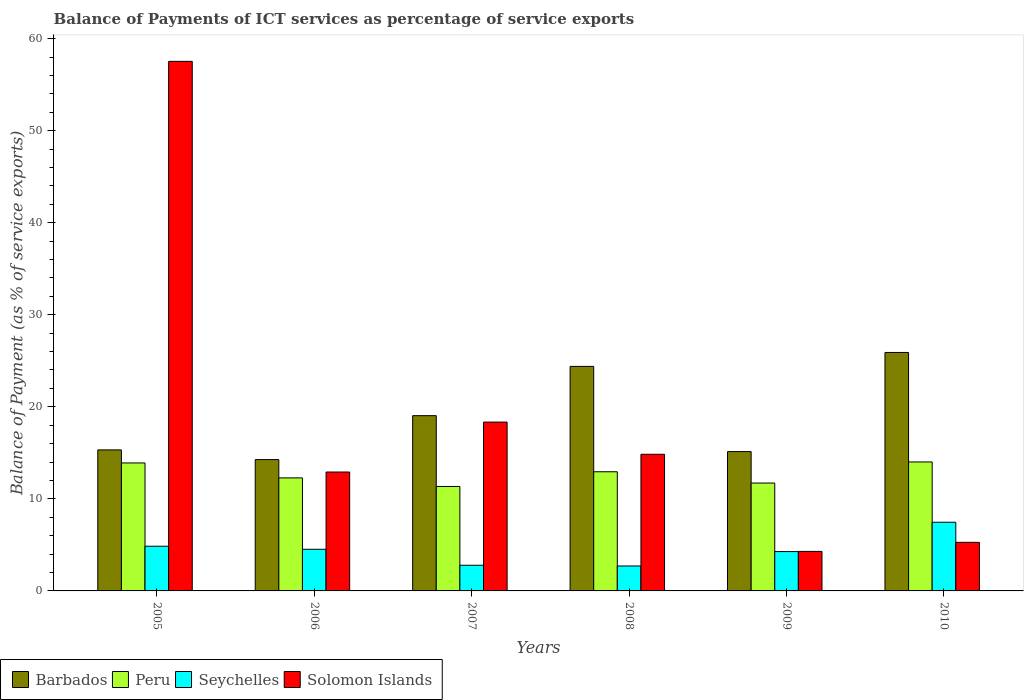How many groups of bars are there?
Give a very brief answer. 6. Are the number of bars on each tick of the X-axis equal?
Give a very brief answer. Yes. How many bars are there on the 5th tick from the left?
Ensure brevity in your answer.  4. How many bars are there on the 2nd tick from the right?
Your answer should be very brief. 4. What is the label of the 2nd group of bars from the left?
Offer a very short reply. 2006. What is the balance of payments of ICT services in Peru in 2007?
Offer a very short reply. 11.35. Across all years, what is the maximum balance of payments of ICT services in Peru?
Offer a terse response. 14.01. Across all years, what is the minimum balance of payments of ICT services in Solomon Islands?
Your answer should be very brief. 4.29. In which year was the balance of payments of ICT services in Barbados minimum?
Give a very brief answer. 2006. What is the total balance of payments of ICT services in Peru in the graph?
Your answer should be very brief. 76.2. What is the difference between the balance of payments of ICT services in Solomon Islands in 2008 and that in 2010?
Your response must be concise. 9.57. What is the difference between the balance of payments of ICT services in Barbados in 2008 and the balance of payments of ICT services in Solomon Islands in 2005?
Ensure brevity in your answer.  -33.13. What is the average balance of payments of ICT services in Peru per year?
Your response must be concise. 12.7. In the year 2007, what is the difference between the balance of payments of ICT services in Peru and balance of payments of ICT services in Seychelles?
Make the answer very short. 8.56. What is the ratio of the balance of payments of ICT services in Seychelles in 2005 to that in 2007?
Keep it short and to the point. 1.74. Is the difference between the balance of payments of ICT services in Peru in 2008 and 2010 greater than the difference between the balance of payments of ICT services in Seychelles in 2008 and 2010?
Your response must be concise. Yes. What is the difference between the highest and the second highest balance of payments of ICT services in Peru?
Ensure brevity in your answer.  0.11. What is the difference between the highest and the lowest balance of payments of ICT services in Seychelles?
Your answer should be very brief. 4.75. Is the sum of the balance of payments of ICT services in Solomon Islands in 2006 and 2007 greater than the maximum balance of payments of ICT services in Seychelles across all years?
Keep it short and to the point. Yes. Is it the case that in every year, the sum of the balance of payments of ICT services in Barbados and balance of payments of ICT services in Seychelles is greater than the sum of balance of payments of ICT services in Peru and balance of payments of ICT services in Solomon Islands?
Ensure brevity in your answer.  Yes. What does the 2nd bar from the left in 2005 represents?
Provide a short and direct response. Peru. What does the 1st bar from the right in 2007 represents?
Your response must be concise. Solomon Islands. Is it the case that in every year, the sum of the balance of payments of ICT services in Peru and balance of payments of ICT services in Seychelles is greater than the balance of payments of ICT services in Solomon Islands?
Provide a succinct answer. No. What is the difference between two consecutive major ticks on the Y-axis?
Offer a terse response. 10. Where does the legend appear in the graph?
Give a very brief answer. Bottom left. How many legend labels are there?
Keep it short and to the point. 4. How are the legend labels stacked?
Provide a succinct answer. Horizontal. What is the title of the graph?
Offer a terse response. Balance of Payments of ICT services as percentage of service exports. What is the label or title of the Y-axis?
Make the answer very short. Balance of Payment (as % of service exports). What is the Balance of Payment (as % of service exports) of Barbados in 2005?
Give a very brief answer. 15.32. What is the Balance of Payment (as % of service exports) of Peru in 2005?
Your response must be concise. 13.9. What is the Balance of Payment (as % of service exports) of Seychelles in 2005?
Your response must be concise. 4.85. What is the Balance of Payment (as % of service exports) in Solomon Islands in 2005?
Your response must be concise. 57.53. What is the Balance of Payment (as % of service exports) in Barbados in 2006?
Your answer should be compact. 14.27. What is the Balance of Payment (as % of service exports) of Peru in 2006?
Keep it short and to the point. 12.28. What is the Balance of Payment (as % of service exports) in Seychelles in 2006?
Ensure brevity in your answer.  4.52. What is the Balance of Payment (as % of service exports) of Solomon Islands in 2006?
Your response must be concise. 12.92. What is the Balance of Payment (as % of service exports) of Barbados in 2007?
Offer a terse response. 19.04. What is the Balance of Payment (as % of service exports) of Peru in 2007?
Provide a succinct answer. 11.35. What is the Balance of Payment (as % of service exports) in Seychelles in 2007?
Offer a terse response. 2.79. What is the Balance of Payment (as % of service exports) of Solomon Islands in 2007?
Your answer should be compact. 18.34. What is the Balance of Payment (as % of service exports) in Barbados in 2008?
Offer a terse response. 24.39. What is the Balance of Payment (as % of service exports) of Peru in 2008?
Your answer should be very brief. 12.94. What is the Balance of Payment (as % of service exports) of Seychelles in 2008?
Give a very brief answer. 2.71. What is the Balance of Payment (as % of service exports) of Solomon Islands in 2008?
Your answer should be compact. 14.84. What is the Balance of Payment (as % of service exports) of Barbados in 2009?
Provide a short and direct response. 15.14. What is the Balance of Payment (as % of service exports) in Peru in 2009?
Provide a succinct answer. 11.72. What is the Balance of Payment (as % of service exports) of Seychelles in 2009?
Ensure brevity in your answer.  4.28. What is the Balance of Payment (as % of service exports) in Solomon Islands in 2009?
Your answer should be compact. 4.29. What is the Balance of Payment (as % of service exports) of Barbados in 2010?
Your answer should be compact. 25.9. What is the Balance of Payment (as % of service exports) of Peru in 2010?
Provide a short and direct response. 14.01. What is the Balance of Payment (as % of service exports) in Seychelles in 2010?
Provide a succinct answer. 7.46. What is the Balance of Payment (as % of service exports) of Solomon Islands in 2010?
Your answer should be very brief. 5.28. Across all years, what is the maximum Balance of Payment (as % of service exports) in Barbados?
Provide a succinct answer. 25.9. Across all years, what is the maximum Balance of Payment (as % of service exports) of Peru?
Your response must be concise. 14.01. Across all years, what is the maximum Balance of Payment (as % of service exports) of Seychelles?
Your answer should be compact. 7.46. Across all years, what is the maximum Balance of Payment (as % of service exports) in Solomon Islands?
Your answer should be very brief. 57.53. Across all years, what is the minimum Balance of Payment (as % of service exports) in Barbados?
Give a very brief answer. 14.27. Across all years, what is the minimum Balance of Payment (as % of service exports) in Peru?
Make the answer very short. 11.35. Across all years, what is the minimum Balance of Payment (as % of service exports) of Seychelles?
Offer a very short reply. 2.71. Across all years, what is the minimum Balance of Payment (as % of service exports) of Solomon Islands?
Offer a very short reply. 4.29. What is the total Balance of Payment (as % of service exports) in Barbados in the graph?
Make the answer very short. 114.06. What is the total Balance of Payment (as % of service exports) in Peru in the graph?
Offer a terse response. 76.2. What is the total Balance of Payment (as % of service exports) in Seychelles in the graph?
Your answer should be very brief. 26.61. What is the total Balance of Payment (as % of service exports) of Solomon Islands in the graph?
Your response must be concise. 113.2. What is the difference between the Balance of Payment (as % of service exports) in Barbados in 2005 and that in 2006?
Your response must be concise. 1.05. What is the difference between the Balance of Payment (as % of service exports) in Peru in 2005 and that in 2006?
Your response must be concise. 1.62. What is the difference between the Balance of Payment (as % of service exports) in Seychelles in 2005 and that in 2006?
Keep it short and to the point. 0.33. What is the difference between the Balance of Payment (as % of service exports) in Solomon Islands in 2005 and that in 2006?
Provide a succinct answer. 44.61. What is the difference between the Balance of Payment (as % of service exports) of Barbados in 2005 and that in 2007?
Make the answer very short. -3.72. What is the difference between the Balance of Payment (as % of service exports) of Peru in 2005 and that in 2007?
Make the answer very short. 2.55. What is the difference between the Balance of Payment (as % of service exports) of Seychelles in 2005 and that in 2007?
Ensure brevity in your answer.  2.07. What is the difference between the Balance of Payment (as % of service exports) of Solomon Islands in 2005 and that in 2007?
Offer a terse response. 39.19. What is the difference between the Balance of Payment (as % of service exports) in Barbados in 2005 and that in 2008?
Offer a very short reply. -9.07. What is the difference between the Balance of Payment (as % of service exports) of Peru in 2005 and that in 2008?
Keep it short and to the point. 0.96. What is the difference between the Balance of Payment (as % of service exports) of Seychelles in 2005 and that in 2008?
Keep it short and to the point. 2.14. What is the difference between the Balance of Payment (as % of service exports) in Solomon Islands in 2005 and that in 2008?
Your answer should be very brief. 42.68. What is the difference between the Balance of Payment (as % of service exports) in Barbados in 2005 and that in 2009?
Your answer should be very brief. 0.18. What is the difference between the Balance of Payment (as % of service exports) in Peru in 2005 and that in 2009?
Give a very brief answer. 2.18. What is the difference between the Balance of Payment (as % of service exports) in Seychelles in 2005 and that in 2009?
Your answer should be compact. 0.58. What is the difference between the Balance of Payment (as % of service exports) in Solomon Islands in 2005 and that in 2009?
Keep it short and to the point. 53.23. What is the difference between the Balance of Payment (as % of service exports) in Barbados in 2005 and that in 2010?
Ensure brevity in your answer.  -10.58. What is the difference between the Balance of Payment (as % of service exports) of Peru in 2005 and that in 2010?
Give a very brief answer. -0.11. What is the difference between the Balance of Payment (as % of service exports) in Seychelles in 2005 and that in 2010?
Ensure brevity in your answer.  -2.61. What is the difference between the Balance of Payment (as % of service exports) in Solomon Islands in 2005 and that in 2010?
Offer a terse response. 52.25. What is the difference between the Balance of Payment (as % of service exports) in Barbados in 2006 and that in 2007?
Your response must be concise. -4.77. What is the difference between the Balance of Payment (as % of service exports) of Peru in 2006 and that in 2007?
Make the answer very short. 0.93. What is the difference between the Balance of Payment (as % of service exports) in Seychelles in 2006 and that in 2007?
Keep it short and to the point. 1.74. What is the difference between the Balance of Payment (as % of service exports) of Solomon Islands in 2006 and that in 2007?
Your answer should be compact. -5.43. What is the difference between the Balance of Payment (as % of service exports) in Barbados in 2006 and that in 2008?
Provide a short and direct response. -10.13. What is the difference between the Balance of Payment (as % of service exports) of Peru in 2006 and that in 2008?
Your answer should be very brief. -0.67. What is the difference between the Balance of Payment (as % of service exports) of Seychelles in 2006 and that in 2008?
Your response must be concise. 1.81. What is the difference between the Balance of Payment (as % of service exports) of Solomon Islands in 2006 and that in 2008?
Your response must be concise. -1.93. What is the difference between the Balance of Payment (as % of service exports) in Barbados in 2006 and that in 2009?
Provide a short and direct response. -0.87. What is the difference between the Balance of Payment (as % of service exports) in Peru in 2006 and that in 2009?
Keep it short and to the point. 0.56. What is the difference between the Balance of Payment (as % of service exports) of Seychelles in 2006 and that in 2009?
Keep it short and to the point. 0.25. What is the difference between the Balance of Payment (as % of service exports) in Solomon Islands in 2006 and that in 2009?
Ensure brevity in your answer.  8.62. What is the difference between the Balance of Payment (as % of service exports) in Barbados in 2006 and that in 2010?
Provide a succinct answer. -11.64. What is the difference between the Balance of Payment (as % of service exports) of Peru in 2006 and that in 2010?
Your answer should be very brief. -1.73. What is the difference between the Balance of Payment (as % of service exports) in Seychelles in 2006 and that in 2010?
Keep it short and to the point. -2.94. What is the difference between the Balance of Payment (as % of service exports) of Solomon Islands in 2006 and that in 2010?
Ensure brevity in your answer.  7.64. What is the difference between the Balance of Payment (as % of service exports) in Barbados in 2007 and that in 2008?
Make the answer very short. -5.35. What is the difference between the Balance of Payment (as % of service exports) of Peru in 2007 and that in 2008?
Provide a succinct answer. -1.6. What is the difference between the Balance of Payment (as % of service exports) of Seychelles in 2007 and that in 2008?
Ensure brevity in your answer.  0.08. What is the difference between the Balance of Payment (as % of service exports) of Solomon Islands in 2007 and that in 2008?
Make the answer very short. 3.5. What is the difference between the Balance of Payment (as % of service exports) of Barbados in 2007 and that in 2009?
Ensure brevity in your answer.  3.9. What is the difference between the Balance of Payment (as % of service exports) in Peru in 2007 and that in 2009?
Keep it short and to the point. -0.37. What is the difference between the Balance of Payment (as % of service exports) of Seychelles in 2007 and that in 2009?
Your answer should be compact. -1.49. What is the difference between the Balance of Payment (as % of service exports) in Solomon Islands in 2007 and that in 2009?
Your response must be concise. 14.05. What is the difference between the Balance of Payment (as % of service exports) of Barbados in 2007 and that in 2010?
Your response must be concise. -6.87. What is the difference between the Balance of Payment (as % of service exports) in Peru in 2007 and that in 2010?
Your response must be concise. -2.66. What is the difference between the Balance of Payment (as % of service exports) of Seychelles in 2007 and that in 2010?
Offer a terse response. -4.67. What is the difference between the Balance of Payment (as % of service exports) of Solomon Islands in 2007 and that in 2010?
Ensure brevity in your answer.  13.06. What is the difference between the Balance of Payment (as % of service exports) in Barbados in 2008 and that in 2009?
Make the answer very short. 9.26. What is the difference between the Balance of Payment (as % of service exports) in Peru in 2008 and that in 2009?
Your response must be concise. 1.22. What is the difference between the Balance of Payment (as % of service exports) in Seychelles in 2008 and that in 2009?
Offer a very short reply. -1.57. What is the difference between the Balance of Payment (as % of service exports) in Solomon Islands in 2008 and that in 2009?
Keep it short and to the point. 10.55. What is the difference between the Balance of Payment (as % of service exports) of Barbados in 2008 and that in 2010?
Your answer should be very brief. -1.51. What is the difference between the Balance of Payment (as % of service exports) in Peru in 2008 and that in 2010?
Keep it short and to the point. -1.07. What is the difference between the Balance of Payment (as % of service exports) in Seychelles in 2008 and that in 2010?
Make the answer very short. -4.75. What is the difference between the Balance of Payment (as % of service exports) in Solomon Islands in 2008 and that in 2010?
Make the answer very short. 9.57. What is the difference between the Balance of Payment (as % of service exports) of Barbados in 2009 and that in 2010?
Make the answer very short. -10.77. What is the difference between the Balance of Payment (as % of service exports) of Peru in 2009 and that in 2010?
Offer a very short reply. -2.29. What is the difference between the Balance of Payment (as % of service exports) of Seychelles in 2009 and that in 2010?
Keep it short and to the point. -3.18. What is the difference between the Balance of Payment (as % of service exports) of Solomon Islands in 2009 and that in 2010?
Provide a short and direct response. -0.98. What is the difference between the Balance of Payment (as % of service exports) in Barbados in 2005 and the Balance of Payment (as % of service exports) in Peru in 2006?
Your answer should be very brief. 3.04. What is the difference between the Balance of Payment (as % of service exports) in Barbados in 2005 and the Balance of Payment (as % of service exports) in Seychelles in 2006?
Offer a very short reply. 10.8. What is the difference between the Balance of Payment (as % of service exports) in Barbados in 2005 and the Balance of Payment (as % of service exports) in Solomon Islands in 2006?
Your answer should be very brief. 2.4. What is the difference between the Balance of Payment (as % of service exports) of Peru in 2005 and the Balance of Payment (as % of service exports) of Seychelles in 2006?
Ensure brevity in your answer.  9.38. What is the difference between the Balance of Payment (as % of service exports) in Peru in 2005 and the Balance of Payment (as % of service exports) in Solomon Islands in 2006?
Your answer should be very brief. 0.99. What is the difference between the Balance of Payment (as % of service exports) of Seychelles in 2005 and the Balance of Payment (as % of service exports) of Solomon Islands in 2006?
Offer a very short reply. -8.06. What is the difference between the Balance of Payment (as % of service exports) of Barbados in 2005 and the Balance of Payment (as % of service exports) of Peru in 2007?
Provide a succinct answer. 3.97. What is the difference between the Balance of Payment (as % of service exports) of Barbados in 2005 and the Balance of Payment (as % of service exports) of Seychelles in 2007?
Keep it short and to the point. 12.53. What is the difference between the Balance of Payment (as % of service exports) in Barbados in 2005 and the Balance of Payment (as % of service exports) in Solomon Islands in 2007?
Provide a short and direct response. -3.02. What is the difference between the Balance of Payment (as % of service exports) of Peru in 2005 and the Balance of Payment (as % of service exports) of Seychelles in 2007?
Give a very brief answer. 11.11. What is the difference between the Balance of Payment (as % of service exports) of Peru in 2005 and the Balance of Payment (as % of service exports) of Solomon Islands in 2007?
Make the answer very short. -4.44. What is the difference between the Balance of Payment (as % of service exports) of Seychelles in 2005 and the Balance of Payment (as % of service exports) of Solomon Islands in 2007?
Ensure brevity in your answer.  -13.49. What is the difference between the Balance of Payment (as % of service exports) in Barbados in 2005 and the Balance of Payment (as % of service exports) in Peru in 2008?
Ensure brevity in your answer.  2.38. What is the difference between the Balance of Payment (as % of service exports) of Barbados in 2005 and the Balance of Payment (as % of service exports) of Seychelles in 2008?
Ensure brevity in your answer.  12.61. What is the difference between the Balance of Payment (as % of service exports) in Barbados in 2005 and the Balance of Payment (as % of service exports) in Solomon Islands in 2008?
Give a very brief answer. 0.48. What is the difference between the Balance of Payment (as % of service exports) in Peru in 2005 and the Balance of Payment (as % of service exports) in Seychelles in 2008?
Your answer should be compact. 11.19. What is the difference between the Balance of Payment (as % of service exports) of Peru in 2005 and the Balance of Payment (as % of service exports) of Solomon Islands in 2008?
Your answer should be compact. -0.94. What is the difference between the Balance of Payment (as % of service exports) of Seychelles in 2005 and the Balance of Payment (as % of service exports) of Solomon Islands in 2008?
Keep it short and to the point. -9.99. What is the difference between the Balance of Payment (as % of service exports) of Barbados in 2005 and the Balance of Payment (as % of service exports) of Peru in 2009?
Your answer should be compact. 3.6. What is the difference between the Balance of Payment (as % of service exports) of Barbados in 2005 and the Balance of Payment (as % of service exports) of Seychelles in 2009?
Your answer should be compact. 11.04. What is the difference between the Balance of Payment (as % of service exports) in Barbados in 2005 and the Balance of Payment (as % of service exports) in Solomon Islands in 2009?
Ensure brevity in your answer.  11.03. What is the difference between the Balance of Payment (as % of service exports) of Peru in 2005 and the Balance of Payment (as % of service exports) of Seychelles in 2009?
Ensure brevity in your answer.  9.63. What is the difference between the Balance of Payment (as % of service exports) of Peru in 2005 and the Balance of Payment (as % of service exports) of Solomon Islands in 2009?
Make the answer very short. 9.61. What is the difference between the Balance of Payment (as % of service exports) of Seychelles in 2005 and the Balance of Payment (as % of service exports) of Solomon Islands in 2009?
Give a very brief answer. 0.56. What is the difference between the Balance of Payment (as % of service exports) in Barbados in 2005 and the Balance of Payment (as % of service exports) in Peru in 2010?
Ensure brevity in your answer.  1.31. What is the difference between the Balance of Payment (as % of service exports) of Barbados in 2005 and the Balance of Payment (as % of service exports) of Seychelles in 2010?
Provide a short and direct response. 7.86. What is the difference between the Balance of Payment (as % of service exports) of Barbados in 2005 and the Balance of Payment (as % of service exports) of Solomon Islands in 2010?
Keep it short and to the point. 10.04. What is the difference between the Balance of Payment (as % of service exports) in Peru in 2005 and the Balance of Payment (as % of service exports) in Seychelles in 2010?
Give a very brief answer. 6.44. What is the difference between the Balance of Payment (as % of service exports) in Peru in 2005 and the Balance of Payment (as % of service exports) in Solomon Islands in 2010?
Your response must be concise. 8.62. What is the difference between the Balance of Payment (as % of service exports) in Seychelles in 2005 and the Balance of Payment (as % of service exports) in Solomon Islands in 2010?
Provide a succinct answer. -0.42. What is the difference between the Balance of Payment (as % of service exports) of Barbados in 2006 and the Balance of Payment (as % of service exports) of Peru in 2007?
Offer a terse response. 2.92. What is the difference between the Balance of Payment (as % of service exports) of Barbados in 2006 and the Balance of Payment (as % of service exports) of Seychelles in 2007?
Your answer should be very brief. 11.48. What is the difference between the Balance of Payment (as % of service exports) of Barbados in 2006 and the Balance of Payment (as % of service exports) of Solomon Islands in 2007?
Give a very brief answer. -4.07. What is the difference between the Balance of Payment (as % of service exports) of Peru in 2006 and the Balance of Payment (as % of service exports) of Seychelles in 2007?
Make the answer very short. 9.49. What is the difference between the Balance of Payment (as % of service exports) of Peru in 2006 and the Balance of Payment (as % of service exports) of Solomon Islands in 2007?
Provide a short and direct response. -6.06. What is the difference between the Balance of Payment (as % of service exports) in Seychelles in 2006 and the Balance of Payment (as % of service exports) in Solomon Islands in 2007?
Make the answer very short. -13.82. What is the difference between the Balance of Payment (as % of service exports) of Barbados in 2006 and the Balance of Payment (as % of service exports) of Peru in 2008?
Your response must be concise. 1.32. What is the difference between the Balance of Payment (as % of service exports) in Barbados in 2006 and the Balance of Payment (as % of service exports) in Seychelles in 2008?
Your answer should be very brief. 11.56. What is the difference between the Balance of Payment (as % of service exports) of Barbados in 2006 and the Balance of Payment (as % of service exports) of Solomon Islands in 2008?
Provide a succinct answer. -0.58. What is the difference between the Balance of Payment (as % of service exports) of Peru in 2006 and the Balance of Payment (as % of service exports) of Seychelles in 2008?
Offer a terse response. 9.57. What is the difference between the Balance of Payment (as % of service exports) in Peru in 2006 and the Balance of Payment (as % of service exports) in Solomon Islands in 2008?
Your answer should be very brief. -2.56. What is the difference between the Balance of Payment (as % of service exports) in Seychelles in 2006 and the Balance of Payment (as % of service exports) in Solomon Islands in 2008?
Make the answer very short. -10.32. What is the difference between the Balance of Payment (as % of service exports) in Barbados in 2006 and the Balance of Payment (as % of service exports) in Peru in 2009?
Your answer should be very brief. 2.55. What is the difference between the Balance of Payment (as % of service exports) in Barbados in 2006 and the Balance of Payment (as % of service exports) in Seychelles in 2009?
Your answer should be very brief. 9.99. What is the difference between the Balance of Payment (as % of service exports) in Barbados in 2006 and the Balance of Payment (as % of service exports) in Solomon Islands in 2009?
Offer a very short reply. 9.97. What is the difference between the Balance of Payment (as % of service exports) in Peru in 2006 and the Balance of Payment (as % of service exports) in Seychelles in 2009?
Provide a succinct answer. 8. What is the difference between the Balance of Payment (as % of service exports) in Peru in 2006 and the Balance of Payment (as % of service exports) in Solomon Islands in 2009?
Keep it short and to the point. 7.99. What is the difference between the Balance of Payment (as % of service exports) of Seychelles in 2006 and the Balance of Payment (as % of service exports) of Solomon Islands in 2009?
Ensure brevity in your answer.  0.23. What is the difference between the Balance of Payment (as % of service exports) of Barbados in 2006 and the Balance of Payment (as % of service exports) of Peru in 2010?
Offer a very short reply. 0.26. What is the difference between the Balance of Payment (as % of service exports) in Barbados in 2006 and the Balance of Payment (as % of service exports) in Seychelles in 2010?
Give a very brief answer. 6.81. What is the difference between the Balance of Payment (as % of service exports) of Barbados in 2006 and the Balance of Payment (as % of service exports) of Solomon Islands in 2010?
Keep it short and to the point. 8.99. What is the difference between the Balance of Payment (as % of service exports) of Peru in 2006 and the Balance of Payment (as % of service exports) of Seychelles in 2010?
Keep it short and to the point. 4.82. What is the difference between the Balance of Payment (as % of service exports) of Peru in 2006 and the Balance of Payment (as % of service exports) of Solomon Islands in 2010?
Offer a very short reply. 7. What is the difference between the Balance of Payment (as % of service exports) in Seychelles in 2006 and the Balance of Payment (as % of service exports) in Solomon Islands in 2010?
Make the answer very short. -0.75. What is the difference between the Balance of Payment (as % of service exports) of Barbados in 2007 and the Balance of Payment (as % of service exports) of Peru in 2008?
Give a very brief answer. 6.09. What is the difference between the Balance of Payment (as % of service exports) of Barbados in 2007 and the Balance of Payment (as % of service exports) of Seychelles in 2008?
Provide a succinct answer. 16.33. What is the difference between the Balance of Payment (as % of service exports) in Barbados in 2007 and the Balance of Payment (as % of service exports) in Solomon Islands in 2008?
Keep it short and to the point. 4.2. What is the difference between the Balance of Payment (as % of service exports) in Peru in 2007 and the Balance of Payment (as % of service exports) in Seychelles in 2008?
Give a very brief answer. 8.64. What is the difference between the Balance of Payment (as % of service exports) of Peru in 2007 and the Balance of Payment (as % of service exports) of Solomon Islands in 2008?
Your answer should be compact. -3.5. What is the difference between the Balance of Payment (as % of service exports) of Seychelles in 2007 and the Balance of Payment (as % of service exports) of Solomon Islands in 2008?
Keep it short and to the point. -12.06. What is the difference between the Balance of Payment (as % of service exports) of Barbados in 2007 and the Balance of Payment (as % of service exports) of Peru in 2009?
Make the answer very short. 7.32. What is the difference between the Balance of Payment (as % of service exports) in Barbados in 2007 and the Balance of Payment (as % of service exports) in Seychelles in 2009?
Offer a very short reply. 14.76. What is the difference between the Balance of Payment (as % of service exports) in Barbados in 2007 and the Balance of Payment (as % of service exports) in Solomon Islands in 2009?
Your answer should be very brief. 14.74. What is the difference between the Balance of Payment (as % of service exports) of Peru in 2007 and the Balance of Payment (as % of service exports) of Seychelles in 2009?
Your response must be concise. 7.07. What is the difference between the Balance of Payment (as % of service exports) in Peru in 2007 and the Balance of Payment (as % of service exports) in Solomon Islands in 2009?
Your answer should be very brief. 7.05. What is the difference between the Balance of Payment (as % of service exports) in Seychelles in 2007 and the Balance of Payment (as % of service exports) in Solomon Islands in 2009?
Keep it short and to the point. -1.51. What is the difference between the Balance of Payment (as % of service exports) of Barbados in 2007 and the Balance of Payment (as % of service exports) of Peru in 2010?
Offer a very short reply. 5.03. What is the difference between the Balance of Payment (as % of service exports) of Barbados in 2007 and the Balance of Payment (as % of service exports) of Seychelles in 2010?
Your answer should be very brief. 11.58. What is the difference between the Balance of Payment (as % of service exports) of Barbados in 2007 and the Balance of Payment (as % of service exports) of Solomon Islands in 2010?
Your response must be concise. 13.76. What is the difference between the Balance of Payment (as % of service exports) of Peru in 2007 and the Balance of Payment (as % of service exports) of Seychelles in 2010?
Offer a very short reply. 3.89. What is the difference between the Balance of Payment (as % of service exports) of Peru in 2007 and the Balance of Payment (as % of service exports) of Solomon Islands in 2010?
Give a very brief answer. 6.07. What is the difference between the Balance of Payment (as % of service exports) of Seychelles in 2007 and the Balance of Payment (as % of service exports) of Solomon Islands in 2010?
Give a very brief answer. -2.49. What is the difference between the Balance of Payment (as % of service exports) of Barbados in 2008 and the Balance of Payment (as % of service exports) of Peru in 2009?
Offer a terse response. 12.67. What is the difference between the Balance of Payment (as % of service exports) in Barbados in 2008 and the Balance of Payment (as % of service exports) in Seychelles in 2009?
Your answer should be very brief. 20.12. What is the difference between the Balance of Payment (as % of service exports) of Barbados in 2008 and the Balance of Payment (as % of service exports) of Solomon Islands in 2009?
Your response must be concise. 20.1. What is the difference between the Balance of Payment (as % of service exports) of Peru in 2008 and the Balance of Payment (as % of service exports) of Seychelles in 2009?
Keep it short and to the point. 8.67. What is the difference between the Balance of Payment (as % of service exports) in Peru in 2008 and the Balance of Payment (as % of service exports) in Solomon Islands in 2009?
Your answer should be very brief. 8.65. What is the difference between the Balance of Payment (as % of service exports) of Seychelles in 2008 and the Balance of Payment (as % of service exports) of Solomon Islands in 2009?
Keep it short and to the point. -1.58. What is the difference between the Balance of Payment (as % of service exports) in Barbados in 2008 and the Balance of Payment (as % of service exports) in Peru in 2010?
Your answer should be very brief. 10.38. What is the difference between the Balance of Payment (as % of service exports) of Barbados in 2008 and the Balance of Payment (as % of service exports) of Seychelles in 2010?
Provide a succinct answer. 16.93. What is the difference between the Balance of Payment (as % of service exports) of Barbados in 2008 and the Balance of Payment (as % of service exports) of Solomon Islands in 2010?
Provide a succinct answer. 19.12. What is the difference between the Balance of Payment (as % of service exports) of Peru in 2008 and the Balance of Payment (as % of service exports) of Seychelles in 2010?
Provide a short and direct response. 5.48. What is the difference between the Balance of Payment (as % of service exports) of Peru in 2008 and the Balance of Payment (as % of service exports) of Solomon Islands in 2010?
Keep it short and to the point. 7.67. What is the difference between the Balance of Payment (as % of service exports) of Seychelles in 2008 and the Balance of Payment (as % of service exports) of Solomon Islands in 2010?
Give a very brief answer. -2.57. What is the difference between the Balance of Payment (as % of service exports) of Barbados in 2009 and the Balance of Payment (as % of service exports) of Peru in 2010?
Your answer should be very brief. 1.13. What is the difference between the Balance of Payment (as % of service exports) of Barbados in 2009 and the Balance of Payment (as % of service exports) of Seychelles in 2010?
Offer a terse response. 7.68. What is the difference between the Balance of Payment (as % of service exports) of Barbados in 2009 and the Balance of Payment (as % of service exports) of Solomon Islands in 2010?
Give a very brief answer. 9.86. What is the difference between the Balance of Payment (as % of service exports) of Peru in 2009 and the Balance of Payment (as % of service exports) of Seychelles in 2010?
Make the answer very short. 4.26. What is the difference between the Balance of Payment (as % of service exports) in Peru in 2009 and the Balance of Payment (as % of service exports) in Solomon Islands in 2010?
Give a very brief answer. 6.44. What is the difference between the Balance of Payment (as % of service exports) in Seychelles in 2009 and the Balance of Payment (as % of service exports) in Solomon Islands in 2010?
Offer a terse response. -1. What is the average Balance of Payment (as % of service exports) of Barbados per year?
Offer a terse response. 19.01. What is the average Balance of Payment (as % of service exports) in Peru per year?
Offer a very short reply. 12.7. What is the average Balance of Payment (as % of service exports) in Seychelles per year?
Your answer should be compact. 4.43. What is the average Balance of Payment (as % of service exports) in Solomon Islands per year?
Make the answer very short. 18.87. In the year 2005, what is the difference between the Balance of Payment (as % of service exports) of Barbados and Balance of Payment (as % of service exports) of Peru?
Your answer should be very brief. 1.42. In the year 2005, what is the difference between the Balance of Payment (as % of service exports) in Barbados and Balance of Payment (as % of service exports) in Seychelles?
Your answer should be compact. 10.47. In the year 2005, what is the difference between the Balance of Payment (as % of service exports) of Barbados and Balance of Payment (as % of service exports) of Solomon Islands?
Provide a succinct answer. -42.21. In the year 2005, what is the difference between the Balance of Payment (as % of service exports) of Peru and Balance of Payment (as % of service exports) of Seychelles?
Offer a terse response. 9.05. In the year 2005, what is the difference between the Balance of Payment (as % of service exports) of Peru and Balance of Payment (as % of service exports) of Solomon Islands?
Your answer should be very brief. -43.63. In the year 2005, what is the difference between the Balance of Payment (as % of service exports) of Seychelles and Balance of Payment (as % of service exports) of Solomon Islands?
Give a very brief answer. -52.67. In the year 2006, what is the difference between the Balance of Payment (as % of service exports) in Barbados and Balance of Payment (as % of service exports) in Peru?
Your answer should be compact. 1.99. In the year 2006, what is the difference between the Balance of Payment (as % of service exports) of Barbados and Balance of Payment (as % of service exports) of Seychelles?
Give a very brief answer. 9.74. In the year 2006, what is the difference between the Balance of Payment (as % of service exports) in Barbados and Balance of Payment (as % of service exports) in Solomon Islands?
Your response must be concise. 1.35. In the year 2006, what is the difference between the Balance of Payment (as % of service exports) of Peru and Balance of Payment (as % of service exports) of Seychelles?
Make the answer very short. 7.76. In the year 2006, what is the difference between the Balance of Payment (as % of service exports) of Peru and Balance of Payment (as % of service exports) of Solomon Islands?
Your answer should be compact. -0.64. In the year 2006, what is the difference between the Balance of Payment (as % of service exports) of Seychelles and Balance of Payment (as % of service exports) of Solomon Islands?
Your answer should be compact. -8.39. In the year 2007, what is the difference between the Balance of Payment (as % of service exports) in Barbados and Balance of Payment (as % of service exports) in Peru?
Your answer should be very brief. 7.69. In the year 2007, what is the difference between the Balance of Payment (as % of service exports) of Barbados and Balance of Payment (as % of service exports) of Seychelles?
Offer a terse response. 16.25. In the year 2007, what is the difference between the Balance of Payment (as % of service exports) of Barbados and Balance of Payment (as % of service exports) of Solomon Islands?
Keep it short and to the point. 0.7. In the year 2007, what is the difference between the Balance of Payment (as % of service exports) in Peru and Balance of Payment (as % of service exports) in Seychelles?
Offer a very short reply. 8.56. In the year 2007, what is the difference between the Balance of Payment (as % of service exports) of Peru and Balance of Payment (as % of service exports) of Solomon Islands?
Ensure brevity in your answer.  -6.99. In the year 2007, what is the difference between the Balance of Payment (as % of service exports) in Seychelles and Balance of Payment (as % of service exports) in Solomon Islands?
Your response must be concise. -15.55. In the year 2008, what is the difference between the Balance of Payment (as % of service exports) of Barbados and Balance of Payment (as % of service exports) of Peru?
Your response must be concise. 11.45. In the year 2008, what is the difference between the Balance of Payment (as % of service exports) in Barbados and Balance of Payment (as % of service exports) in Seychelles?
Your response must be concise. 21.68. In the year 2008, what is the difference between the Balance of Payment (as % of service exports) of Barbados and Balance of Payment (as % of service exports) of Solomon Islands?
Make the answer very short. 9.55. In the year 2008, what is the difference between the Balance of Payment (as % of service exports) in Peru and Balance of Payment (as % of service exports) in Seychelles?
Keep it short and to the point. 10.23. In the year 2008, what is the difference between the Balance of Payment (as % of service exports) of Peru and Balance of Payment (as % of service exports) of Solomon Islands?
Ensure brevity in your answer.  -1.9. In the year 2008, what is the difference between the Balance of Payment (as % of service exports) of Seychelles and Balance of Payment (as % of service exports) of Solomon Islands?
Offer a very short reply. -12.13. In the year 2009, what is the difference between the Balance of Payment (as % of service exports) of Barbados and Balance of Payment (as % of service exports) of Peru?
Provide a short and direct response. 3.42. In the year 2009, what is the difference between the Balance of Payment (as % of service exports) in Barbados and Balance of Payment (as % of service exports) in Seychelles?
Provide a short and direct response. 10.86. In the year 2009, what is the difference between the Balance of Payment (as % of service exports) in Barbados and Balance of Payment (as % of service exports) in Solomon Islands?
Provide a succinct answer. 10.84. In the year 2009, what is the difference between the Balance of Payment (as % of service exports) in Peru and Balance of Payment (as % of service exports) in Seychelles?
Give a very brief answer. 7.44. In the year 2009, what is the difference between the Balance of Payment (as % of service exports) of Peru and Balance of Payment (as % of service exports) of Solomon Islands?
Your answer should be very brief. 7.43. In the year 2009, what is the difference between the Balance of Payment (as % of service exports) of Seychelles and Balance of Payment (as % of service exports) of Solomon Islands?
Make the answer very short. -0.02. In the year 2010, what is the difference between the Balance of Payment (as % of service exports) in Barbados and Balance of Payment (as % of service exports) in Peru?
Offer a very short reply. 11.89. In the year 2010, what is the difference between the Balance of Payment (as % of service exports) of Barbados and Balance of Payment (as % of service exports) of Seychelles?
Your answer should be very brief. 18.44. In the year 2010, what is the difference between the Balance of Payment (as % of service exports) in Barbados and Balance of Payment (as % of service exports) in Solomon Islands?
Ensure brevity in your answer.  20.63. In the year 2010, what is the difference between the Balance of Payment (as % of service exports) of Peru and Balance of Payment (as % of service exports) of Seychelles?
Offer a terse response. 6.55. In the year 2010, what is the difference between the Balance of Payment (as % of service exports) in Peru and Balance of Payment (as % of service exports) in Solomon Islands?
Provide a succinct answer. 8.73. In the year 2010, what is the difference between the Balance of Payment (as % of service exports) of Seychelles and Balance of Payment (as % of service exports) of Solomon Islands?
Give a very brief answer. 2.18. What is the ratio of the Balance of Payment (as % of service exports) in Barbados in 2005 to that in 2006?
Offer a very short reply. 1.07. What is the ratio of the Balance of Payment (as % of service exports) in Peru in 2005 to that in 2006?
Make the answer very short. 1.13. What is the ratio of the Balance of Payment (as % of service exports) in Seychelles in 2005 to that in 2006?
Give a very brief answer. 1.07. What is the ratio of the Balance of Payment (as % of service exports) of Solomon Islands in 2005 to that in 2006?
Ensure brevity in your answer.  4.45. What is the ratio of the Balance of Payment (as % of service exports) in Barbados in 2005 to that in 2007?
Offer a very short reply. 0.8. What is the ratio of the Balance of Payment (as % of service exports) of Peru in 2005 to that in 2007?
Give a very brief answer. 1.23. What is the ratio of the Balance of Payment (as % of service exports) in Seychelles in 2005 to that in 2007?
Ensure brevity in your answer.  1.74. What is the ratio of the Balance of Payment (as % of service exports) in Solomon Islands in 2005 to that in 2007?
Your answer should be very brief. 3.14. What is the ratio of the Balance of Payment (as % of service exports) in Barbados in 2005 to that in 2008?
Your response must be concise. 0.63. What is the ratio of the Balance of Payment (as % of service exports) in Peru in 2005 to that in 2008?
Your answer should be very brief. 1.07. What is the ratio of the Balance of Payment (as % of service exports) of Seychelles in 2005 to that in 2008?
Offer a terse response. 1.79. What is the ratio of the Balance of Payment (as % of service exports) of Solomon Islands in 2005 to that in 2008?
Your answer should be very brief. 3.88. What is the ratio of the Balance of Payment (as % of service exports) in Barbados in 2005 to that in 2009?
Give a very brief answer. 1.01. What is the ratio of the Balance of Payment (as % of service exports) in Peru in 2005 to that in 2009?
Offer a very short reply. 1.19. What is the ratio of the Balance of Payment (as % of service exports) in Seychelles in 2005 to that in 2009?
Offer a very short reply. 1.14. What is the ratio of the Balance of Payment (as % of service exports) in Solomon Islands in 2005 to that in 2009?
Make the answer very short. 13.4. What is the ratio of the Balance of Payment (as % of service exports) of Barbados in 2005 to that in 2010?
Provide a short and direct response. 0.59. What is the ratio of the Balance of Payment (as % of service exports) of Peru in 2005 to that in 2010?
Your answer should be very brief. 0.99. What is the ratio of the Balance of Payment (as % of service exports) of Seychelles in 2005 to that in 2010?
Provide a short and direct response. 0.65. What is the ratio of the Balance of Payment (as % of service exports) in Solomon Islands in 2005 to that in 2010?
Offer a terse response. 10.9. What is the ratio of the Balance of Payment (as % of service exports) in Barbados in 2006 to that in 2007?
Your response must be concise. 0.75. What is the ratio of the Balance of Payment (as % of service exports) in Peru in 2006 to that in 2007?
Keep it short and to the point. 1.08. What is the ratio of the Balance of Payment (as % of service exports) of Seychelles in 2006 to that in 2007?
Give a very brief answer. 1.62. What is the ratio of the Balance of Payment (as % of service exports) of Solomon Islands in 2006 to that in 2007?
Offer a terse response. 0.7. What is the ratio of the Balance of Payment (as % of service exports) in Barbados in 2006 to that in 2008?
Make the answer very short. 0.58. What is the ratio of the Balance of Payment (as % of service exports) of Peru in 2006 to that in 2008?
Keep it short and to the point. 0.95. What is the ratio of the Balance of Payment (as % of service exports) of Seychelles in 2006 to that in 2008?
Give a very brief answer. 1.67. What is the ratio of the Balance of Payment (as % of service exports) in Solomon Islands in 2006 to that in 2008?
Provide a short and direct response. 0.87. What is the ratio of the Balance of Payment (as % of service exports) of Barbados in 2006 to that in 2009?
Your response must be concise. 0.94. What is the ratio of the Balance of Payment (as % of service exports) in Peru in 2006 to that in 2009?
Your answer should be very brief. 1.05. What is the ratio of the Balance of Payment (as % of service exports) of Seychelles in 2006 to that in 2009?
Ensure brevity in your answer.  1.06. What is the ratio of the Balance of Payment (as % of service exports) of Solomon Islands in 2006 to that in 2009?
Your response must be concise. 3.01. What is the ratio of the Balance of Payment (as % of service exports) in Barbados in 2006 to that in 2010?
Ensure brevity in your answer.  0.55. What is the ratio of the Balance of Payment (as % of service exports) of Peru in 2006 to that in 2010?
Give a very brief answer. 0.88. What is the ratio of the Balance of Payment (as % of service exports) in Seychelles in 2006 to that in 2010?
Ensure brevity in your answer.  0.61. What is the ratio of the Balance of Payment (as % of service exports) in Solomon Islands in 2006 to that in 2010?
Your answer should be very brief. 2.45. What is the ratio of the Balance of Payment (as % of service exports) in Barbados in 2007 to that in 2008?
Offer a terse response. 0.78. What is the ratio of the Balance of Payment (as % of service exports) of Peru in 2007 to that in 2008?
Keep it short and to the point. 0.88. What is the ratio of the Balance of Payment (as % of service exports) in Seychelles in 2007 to that in 2008?
Your answer should be very brief. 1.03. What is the ratio of the Balance of Payment (as % of service exports) in Solomon Islands in 2007 to that in 2008?
Ensure brevity in your answer.  1.24. What is the ratio of the Balance of Payment (as % of service exports) of Barbados in 2007 to that in 2009?
Ensure brevity in your answer.  1.26. What is the ratio of the Balance of Payment (as % of service exports) in Peru in 2007 to that in 2009?
Provide a short and direct response. 0.97. What is the ratio of the Balance of Payment (as % of service exports) in Seychelles in 2007 to that in 2009?
Keep it short and to the point. 0.65. What is the ratio of the Balance of Payment (as % of service exports) of Solomon Islands in 2007 to that in 2009?
Give a very brief answer. 4.27. What is the ratio of the Balance of Payment (as % of service exports) of Barbados in 2007 to that in 2010?
Offer a terse response. 0.73. What is the ratio of the Balance of Payment (as % of service exports) in Peru in 2007 to that in 2010?
Your response must be concise. 0.81. What is the ratio of the Balance of Payment (as % of service exports) of Seychelles in 2007 to that in 2010?
Make the answer very short. 0.37. What is the ratio of the Balance of Payment (as % of service exports) in Solomon Islands in 2007 to that in 2010?
Make the answer very short. 3.48. What is the ratio of the Balance of Payment (as % of service exports) in Barbados in 2008 to that in 2009?
Provide a short and direct response. 1.61. What is the ratio of the Balance of Payment (as % of service exports) of Peru in 2008 to that in 2009?
Make the answer very short. 1.1. What is the ratio of the Balance of Payment (as % of service exports) of Seychelles in 2008 to that in 2009?
Provide a succinct answer. 0.63. What is the ratio of the Balance of Payment (as % of service exports) of Solomon Islands in 2008 to that in 2009?
Ensure brevity in your answer.  3.46. What is the ratio of the Balance of Payment (as % of service exports) in Barbados in 2008 to that in 2010?
Your answer should be compact. 0.94. What is the ratio of the Balance of Payment (as % of service exports) in Peru in 2008 to that in 2010?
Your response must be concise. 0.92. What is the ratio of the Balance of Payment (as % of service exports) in Seychelles in 2008 to that in 2010?
Offer a terse response. 0.36. What is the ratio of the Balance of Payment (as % of service exports) of Solomon Islands in 2008 to that in 2010?
Your answer should be very brief. 2.81. What is the ratio of the Balance of Payment (as % of service exports) in Barbados in 2009 to that in 2010?
Your response must be concise. 0.58. What is the ratio of the Balance of Payment (as % of service exports) of Peru in 2009 to that in 2010?
Ensure brevity in your answer.  0.84. What is the ratio of the Balance of Payment (as % of service exports) in Seychelles in 2009 to that in 2010?
Offer a very short reply. 0.57. What is the ratio of the Balance of Payment (as % of service exports) in Solomon Islands in 2009 to that in 2010?
Provide a short and direct response. 0.81. What is the difference between the highest and the second highest Balance of Payment (as % of service exports) in Barbados?
Offer a terse response. 1.51. What is the difference between the highest and the second highest Balance of Payment (as % of service exports) in Peru?
Provide a short and direct response. 0.11. What is the difference between the highest and the second highest Balance of Payment (as % of service exports) of Seychelles?
Provide a short and direct response. 2.61. What is the difference between the highest and the second highest Balance of Payment (as % of service exports) in Solomon Islands?
Your response must be concise. 39.19. What is the difference between the highest and the lowest Balance of Payment (as % of service exports) in Barbados?
Your answer should be compact. 11.64. What is the difference between the highest and the lowest Balance of Payment (as % of service exports) of Peru?
Ensure brevity in your answer.  2.66. What is the difference between the highest and the lowest Balance of Payment (as % of service exports) of Seychelles?
Provide a short and direct response. 4.75. What is the difference between the highest and the lowest Balance of Payment (as % of service exports) of Solomon Islands?
Provide a short and direct response. 53.23. 